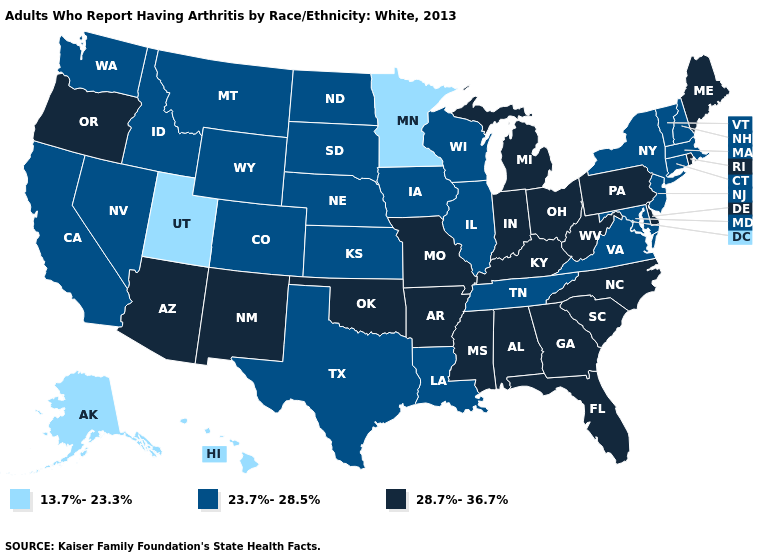Among the states that border South Carolina , which have the lowest value?
Write a very short answer. Georgia, North Carolina. Which states hav the highest value in the MidWest?
Write a very short answer. Indiana, Michigan, Missouri, Ohio. Does the map have missing data?
Be succinct. No. Is the legend a continuous bar?
Quick response, please. No. What is the value of Hawaii?
Be succinct. 13.7%-23.3%. Does the map have missing data?
Concise answer only. No. What is the value of Indiana?
Short answer required. 28.7%-36.7%. What is the value of Idaho?
Keep it brief. 23.7%-28.5%. Does Nevada have the highest value in the USA?
Quick response, please. No. Among the states that border Ohio , which have the lowest value?
Quick response, please. Indiana, Kentucky, Michigan, Pennsylvania, West Virginia. Name the states that have a value in the range 23.7%-28.5%?
Concise answer only. California, Colorado, Connecticut, Idaho, Illinois, Iowa, Kansas, Louisiana, Maryland, Massachusetts, Montana, Nebraska, Nevada, New Hampshire, New Jersey, New York, North Dakota, South Dakota, Tennessee, Texas, Vermont, Virginia, Washington, Wisconsin, Wyoming. Does Oregon have the same value as North Carolina?
Answer briefly. Yes. What is the value of Vermont?
Answer briefly. 23.7%-28.5%. What is the value of Colorado?
Short answer required. 23.7%-28.5%. Which states have the highest value in the USA?
Be succinct. Alabama, Arizona, Arkansas, Delaware, Florida, Georgia, Indiana, Kentucky, Maine, Michigan, Mississippi, Missouri, New Mexico, North Carolina, Ohio, Oklahoma, Oregon, Pennsylvania, Rhode Island, South Carolina, West Virginia. 